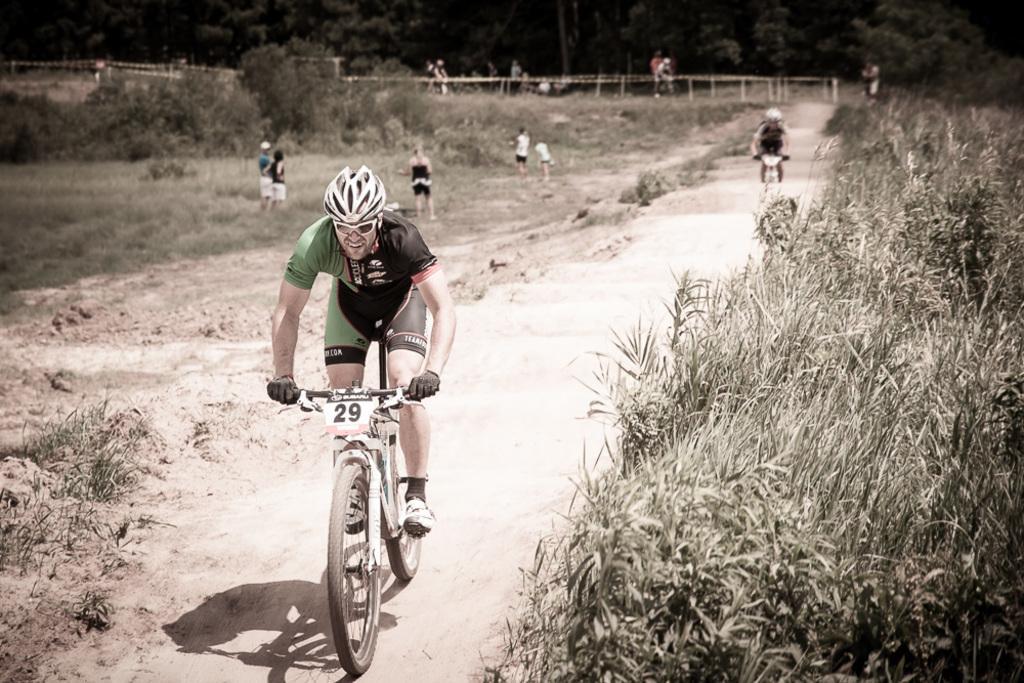How would you summarize this image in a sentence or two? This image consists of many people. In the front, we can see a man riding bicycle. At the bottom, there is a road. On the right, there are plants. On the left, we can see green grass on the ground. In the background, there are many trees. 